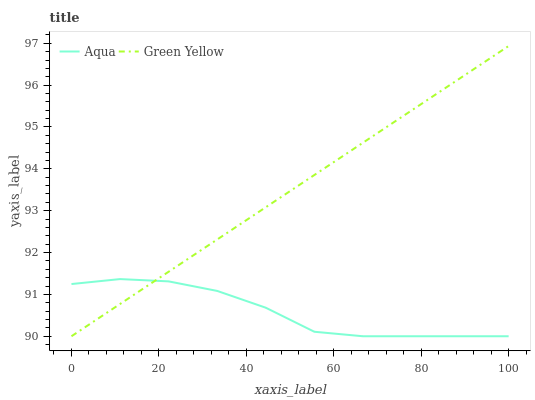Does Aqua have the minimum area under the curve?
Answer yes or no. Yes. Does Green Yellow have the maximum area under the curve?
Answer yes or no. Yes. Does Aqua have the maximum area under the curve?
Answer yes or no. No. Is Green Yellow the smoothest?
Answer yes or no. Yes. Is Aqua the roughest?
Answer yes or no. Yes. Is Aqua the smoothest?
Answer yes or no. No. Does Green Yellow have the lowest value?
Answer yes or no. Yes. Does Green Yellow have the highest value?
Answer yes or no. Yes. Does Aqua have the highest value?
Answer yes or no. No. Does Aqua intersect Green Yellow?
Answer yes or no. Yes. Is Aqua less than Green Yellow?
Answer yes or no. No. Is Aqua greater than Green Yellow?
Answer yes or no. No. 